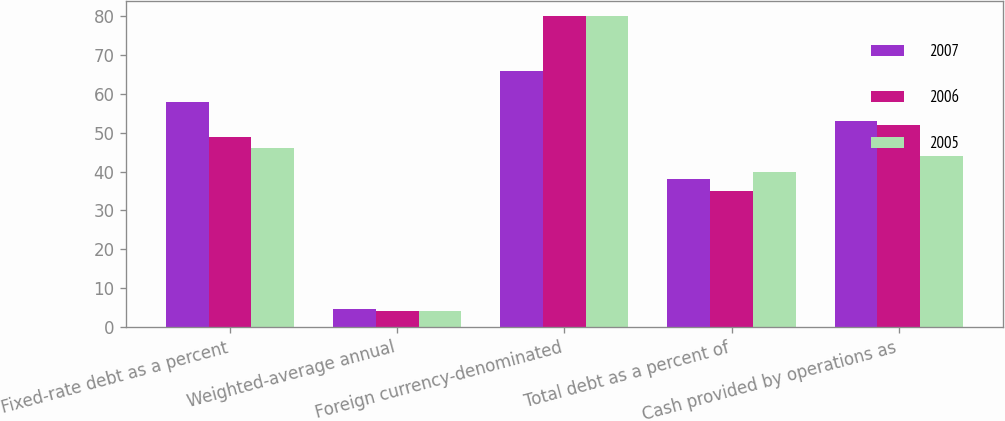<chart> <loc_0><loc_0><loc_500><loc_500><stacked_bar_chart><ecel><fcel>Fixed-rate debt as a percent<fcel>Weighted-average annual<fcel>Foreign currency-denominated<fcel>Total debt as a percent of<fcel>Cash provided by operations as<nl><fcel>2007<fcel>58<fcel>4.7<fcel>66<fcel>38<fcel>53<nl><fcel>2006<fcel>49<fcel>4.1<fcel>80<fcel>35<fcel>52<nl><fcel>2005<fcel>46<fcel>4.1<fcel>80<fcel>40<fcel>44<nl></chart> 